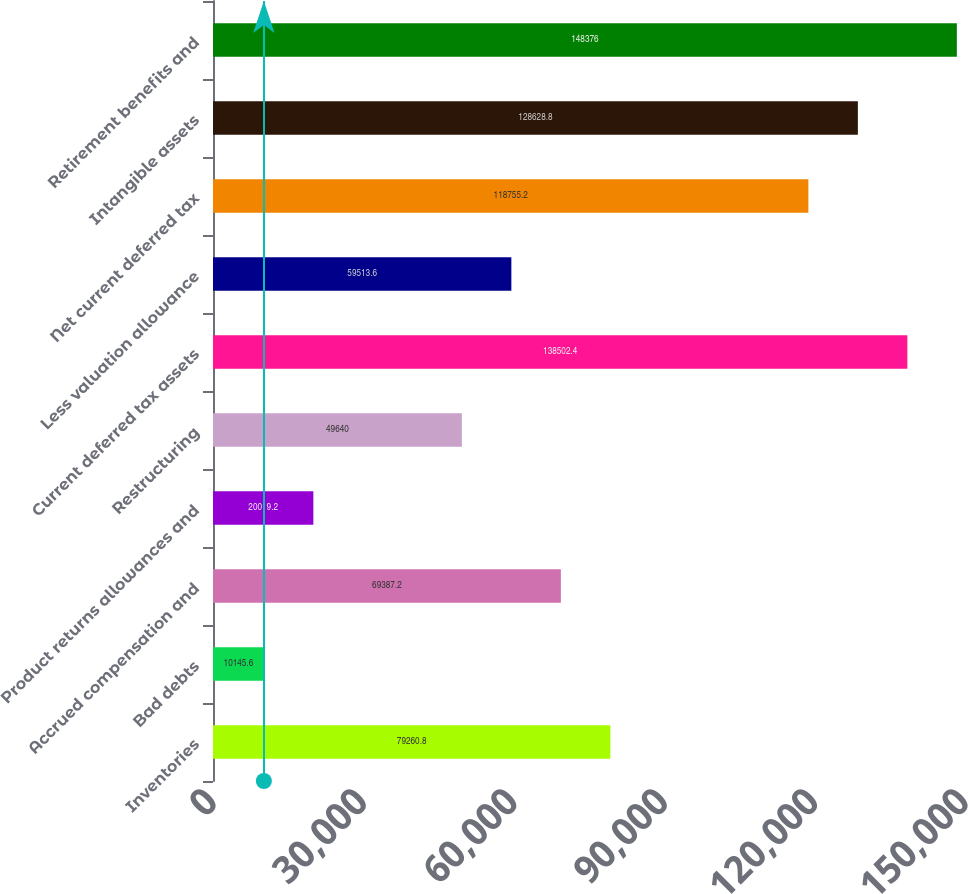<chart> <loc_0><loc_0><loc_500><loc_500><bar_chart><fcel>Inventories<fcel>Bad debts<fcel>Accrued compensation and<fcel>Product returns allowances and<fcel>Restructuring<fcel>Current deferred tax assets<fcel>Less valuation allowance<fcel>Net current deferred tax<fcel>Intangible assets<fcel>Retirement benefits and<nl><fcel>79260.8<fcel>10145.6<fcel>69387.2<fcel>20019.2<fcel>49640<fcel>138502<fcel>59513.6<fcel>118755<fcel>128629<fcel>148376<nl></chart> 